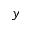<formula> <loc_0><loc_0><loc_500><loc_500>^ { y }</formula> 